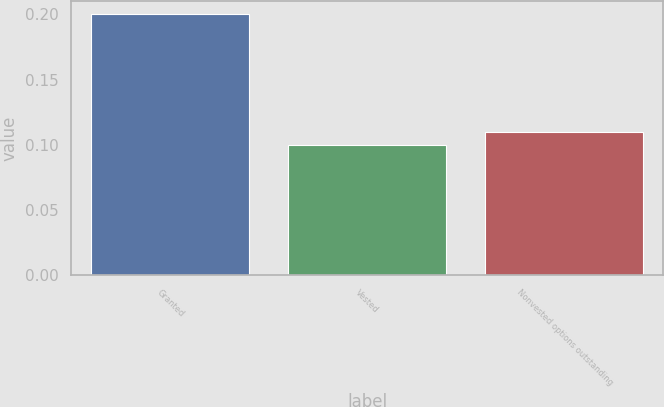Convert chart to OTSL. <chart><loc_0><loc_0><loc_500><loc_500><bar_chart><fcel>Granted<fcel>Vested<fcel>Nonvested options outstanding<nl><fcel>0.2<fcel>0.1<fcel>0.11<nl></chart> 